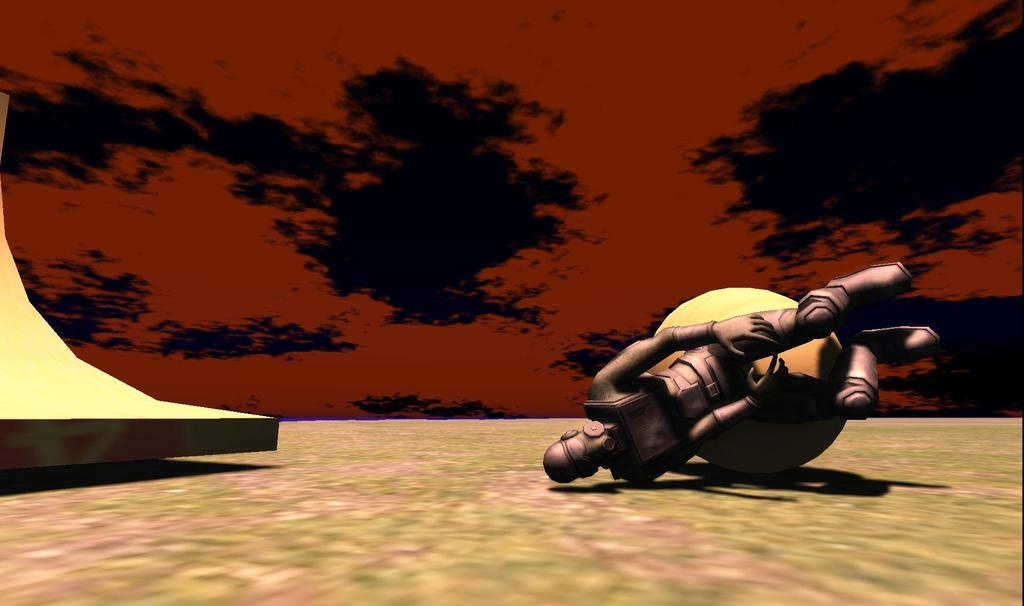What type of image is this? The image is animated. What is the main subject in the image? There is a robot in the image. Can you describe the shape of an object in the image? There is a round shaped object in the image. What is located on the left side of the robot? There is another object on the left side of the robot, which looks like a wall. How many rabbits are playing music in the image? There are no rabbits or music present in the image. What happens when the round shaped object bursts in the image? There is no round shaped object bursting in the image. 